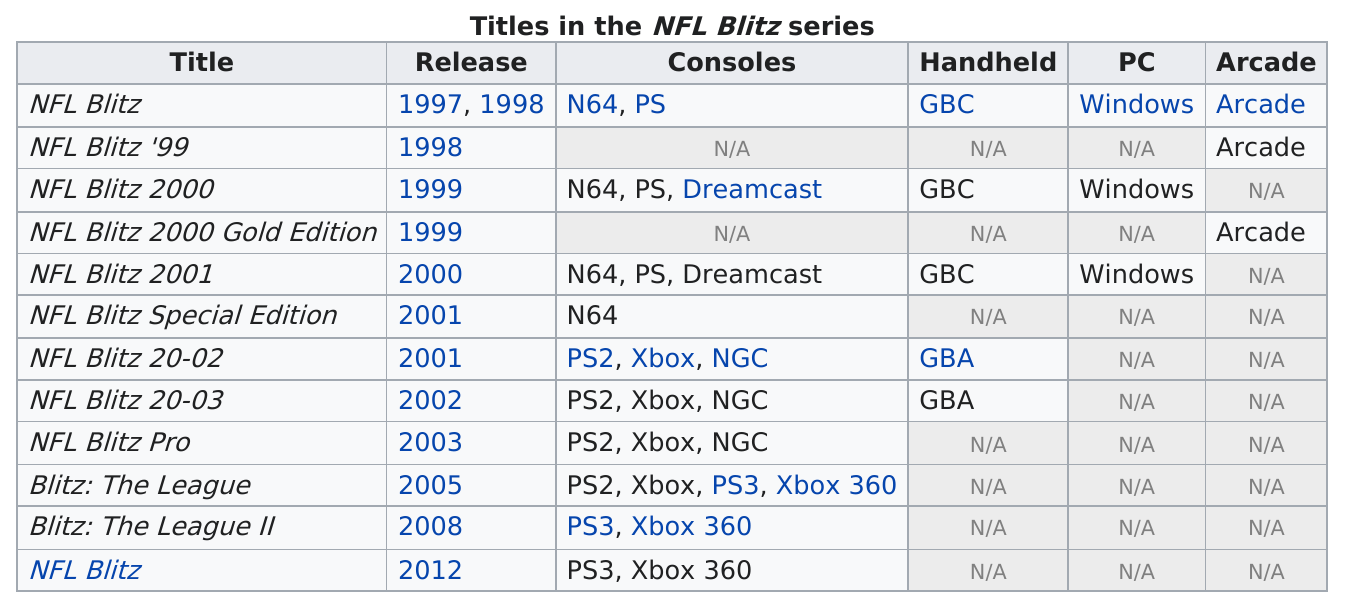Specify some key components in this picture. It is estimated that a total of 8 gaming consoles were released for NFL Blitz. NFL Blitz Special Edition and NFL Blitz 20-02 were both released in the year 2001. NFL Blitz 20-02 was released in the same year as the special edition of the game, which was also named NFL Blitz. As of the arcade releases, a total of 3 titles were released. The release year of NFL Blitz Pro was 2003. 